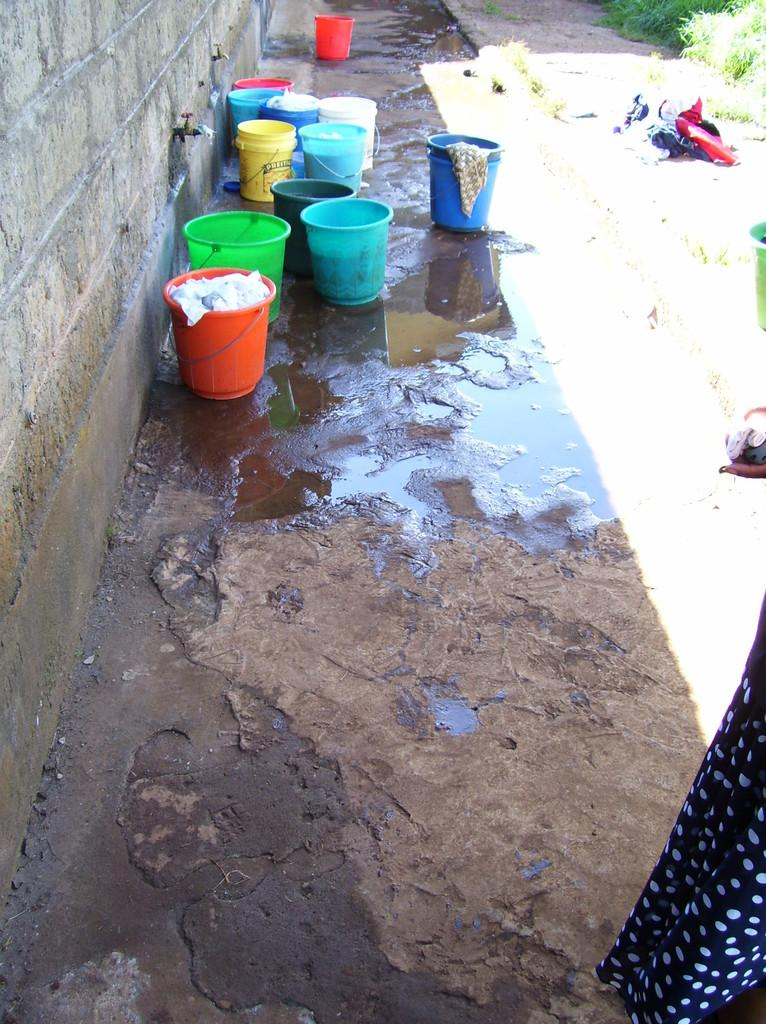What objects are present in the image that are used for holding or storing items? There are different colored buckets in the image. Where are the buckets located in the image? The buckets are placed on the land. What can be seen on the left side of the image? There is a wall on the left side of the image. Can you tell me how many lawyers are standing next to the tree in the image? There is no tree or lawyer present in the image. What type of harbor can be seen in the background of the image? There is no harbor visible in the image; it features different colored buckets placed on the land with a wall on the left side. 